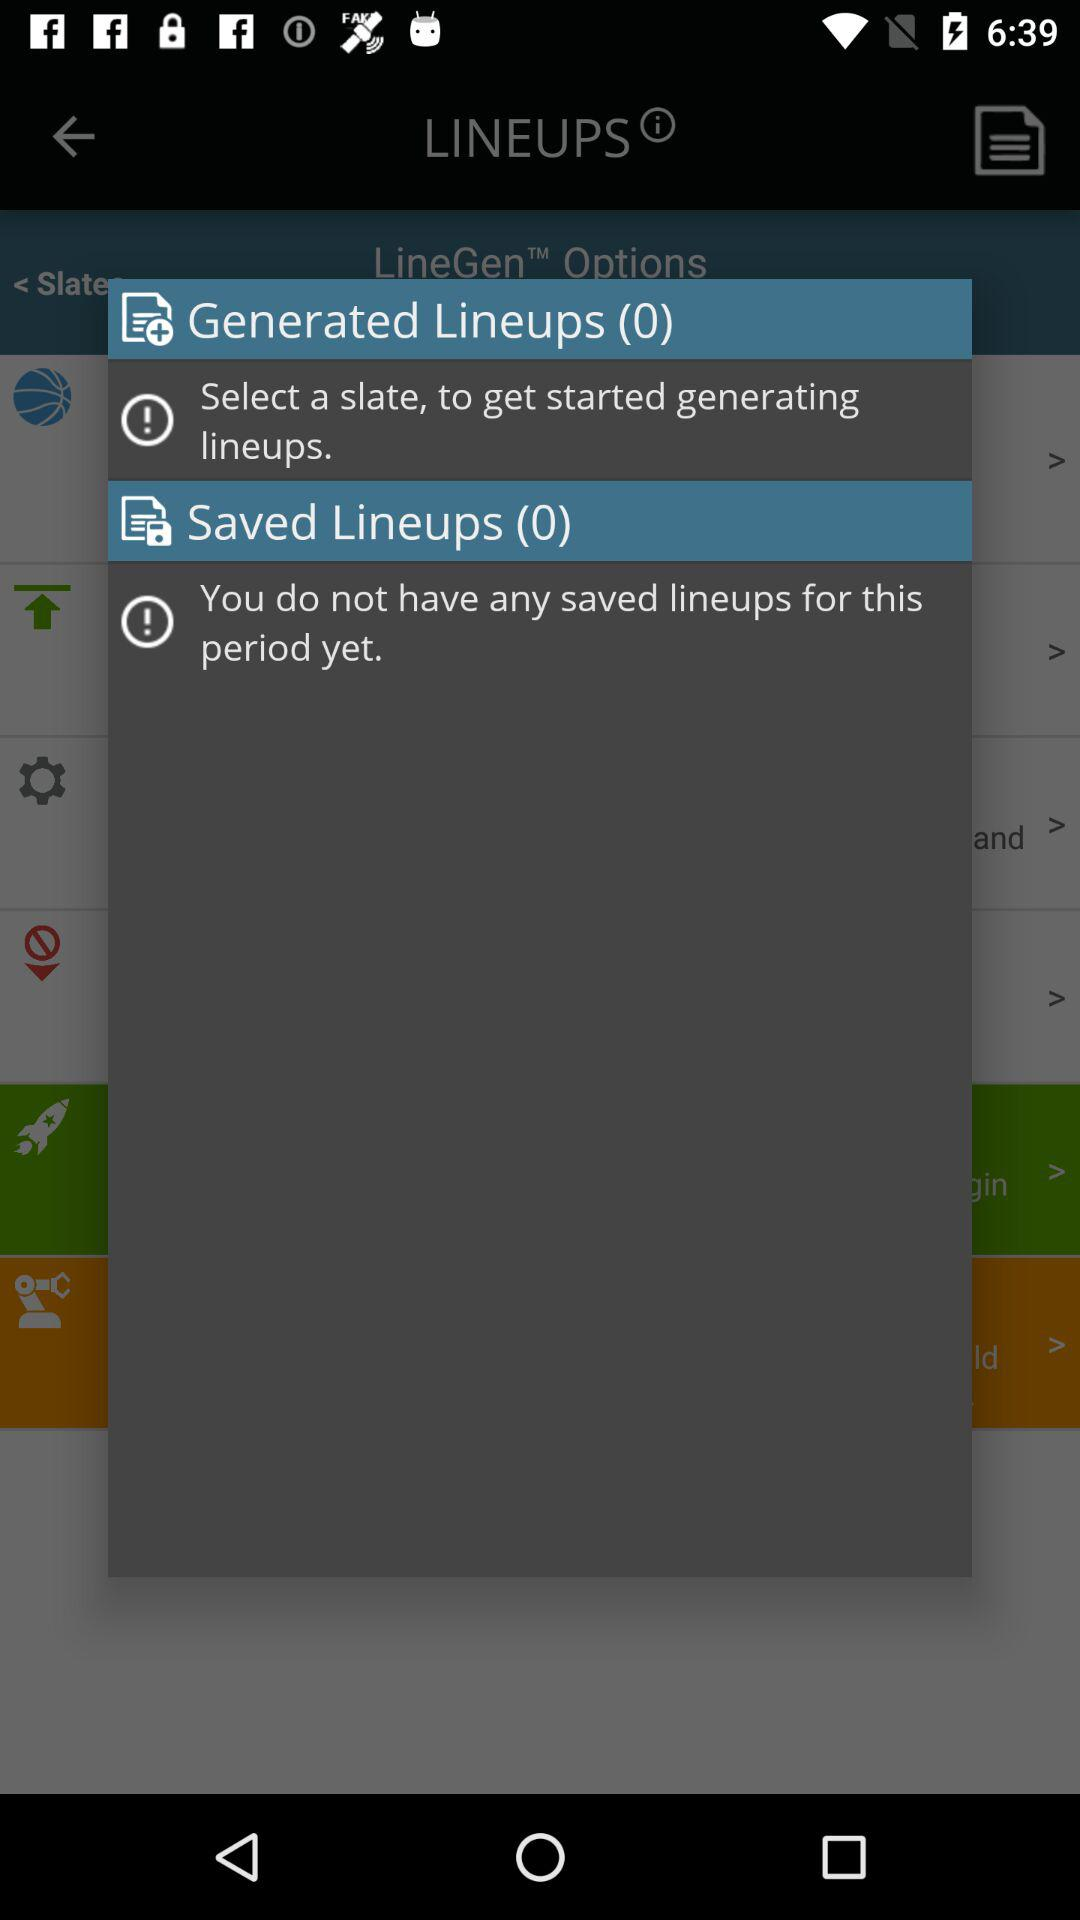What is the total number of lineups that have been generated? The total number of lineups that have been generated is 0. 